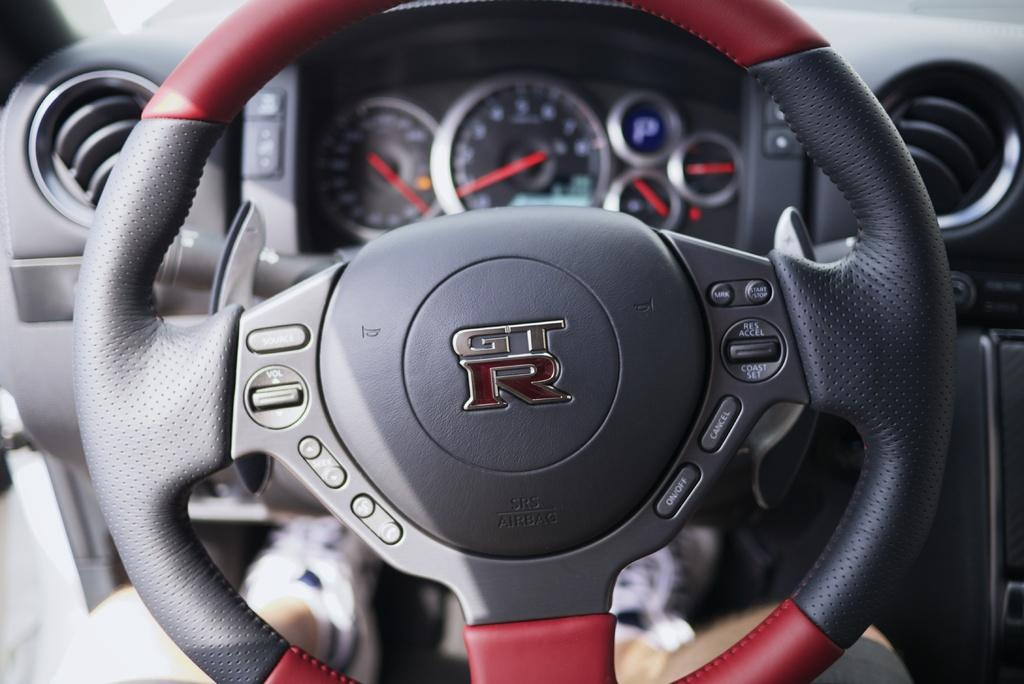What part of a vehicle is visible in the image? The steering part of a vehicle is visible in the image. What instrument is present in the image that measures speed? There is a speedometer in the image. What type of secretary is sitting next to the speedometer in the image? There is no secretary present in the image; it only features a steering part and a speedometer. 